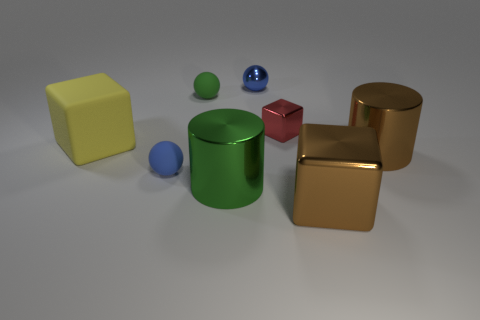There is a green cylinder that is made of the same material as the red thing; what size is it?
Provide a succinct answer. Large. Are there an equal number of big green shiny cylinders to the right of the brown metal cylinder and tiny red matte things?
Your answer should be very brief. Yes. Do the tiny blue object that is behind the green ball and the tiny thing that is in front of the yellow block have the same shape?
Give a very brief answer. Yes. There is another big object that is the same shape as the yellow rubber object; what material is it?
Offer a terse response. Metal. What is the color of the metallic object that is in front of the small red object and on the left side of the brown block?
Provide a succinct answer. Green. Are there any small matte spheres that are in front of the large metal cylinder to the right of the small object that is on the right side of the tiny blue shiny object?
Your answer should be very brief. Yes. How many objects are either big yellow rubber things or metallic things?
Make the answer very short. 6. Are the large brown block and the brown cylinder that is to the right of the tiny red object made of the same material?
Provide a short and direct response. Yes. Is there anything else that is the same color as the large rubber cube?
Provide a short and direct response. No. How many objects are blue balls that are behind the tiny green object or tiny rubber things that are right of the blue rubber sphere?
Your answer should be compact. 2. 